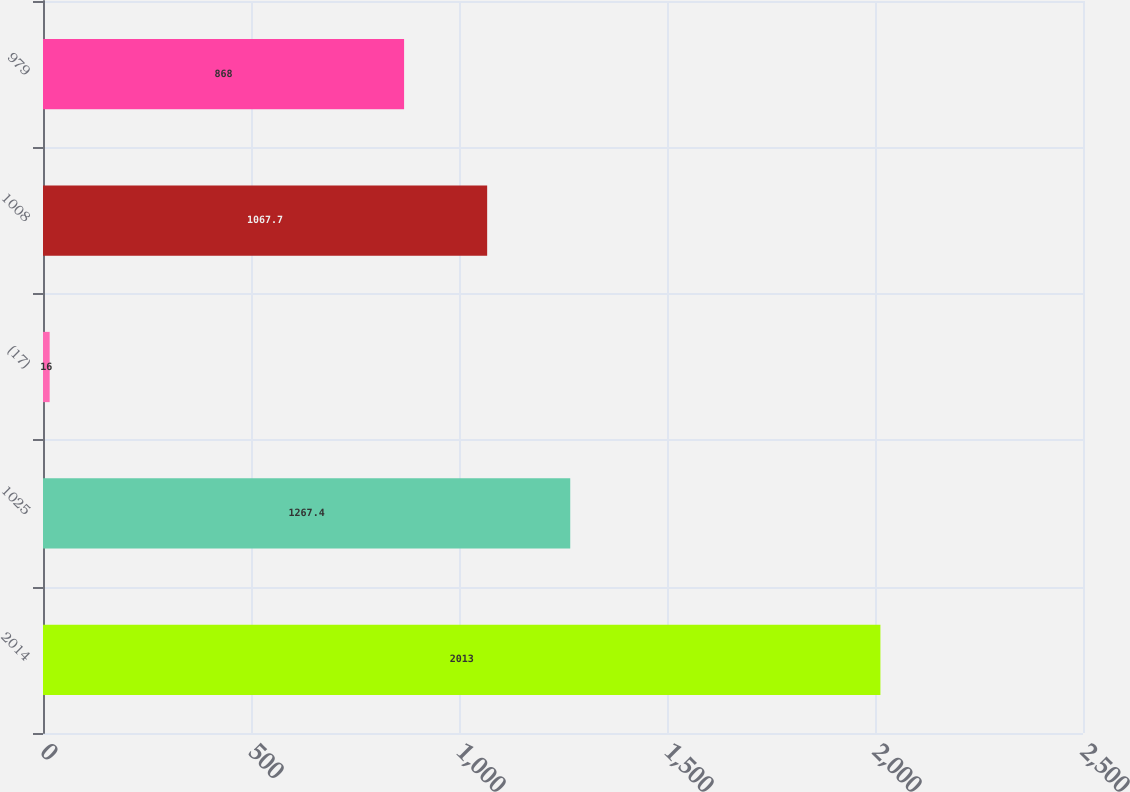Convert chart to OTSL. <chart><loc_0><loc_0><loc_500><loc_500><bar_chart><fcel>2014<fcel>1025<fcel>(17)<fcel>1008<fcel>979<nl><fcel>2013<fcel>1267.4<fcel>16<fcel>1067.7<fcel>868<nl></chart> 